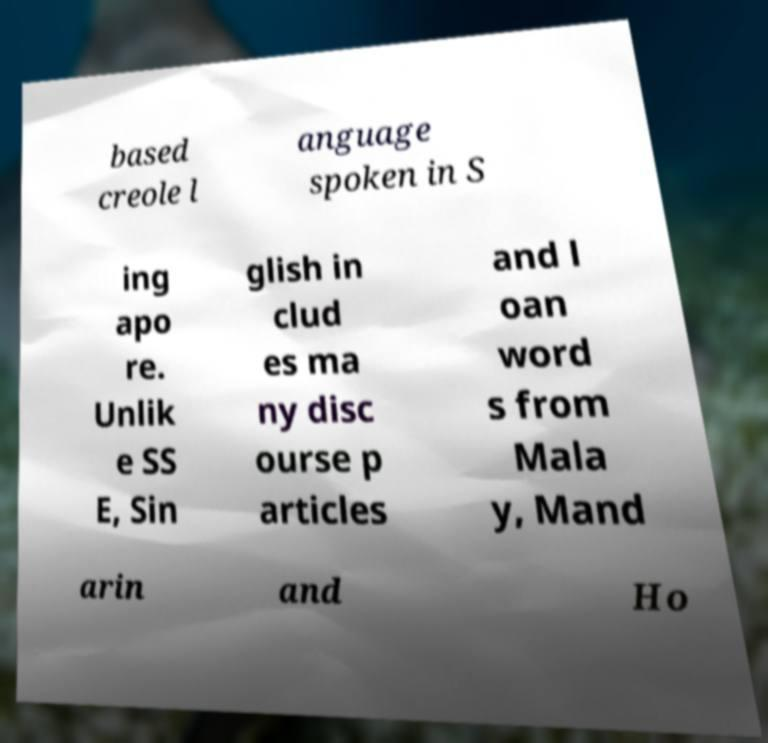Could you assist in decoding the text presented in this image and type it out clearly? based creole l anguage spoken in S ing apo re. Unlik e SS E, Sin glish in clud es ma ny disc ourse p articles and l oan word s from Mala y, Mand arin and Ho 